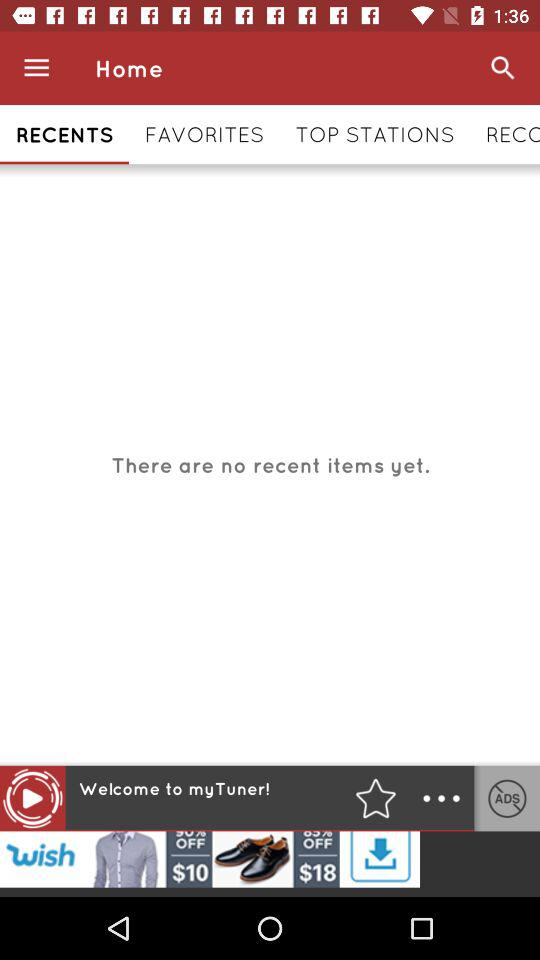Are there any recent items yet? No, there are no recent items yet. 